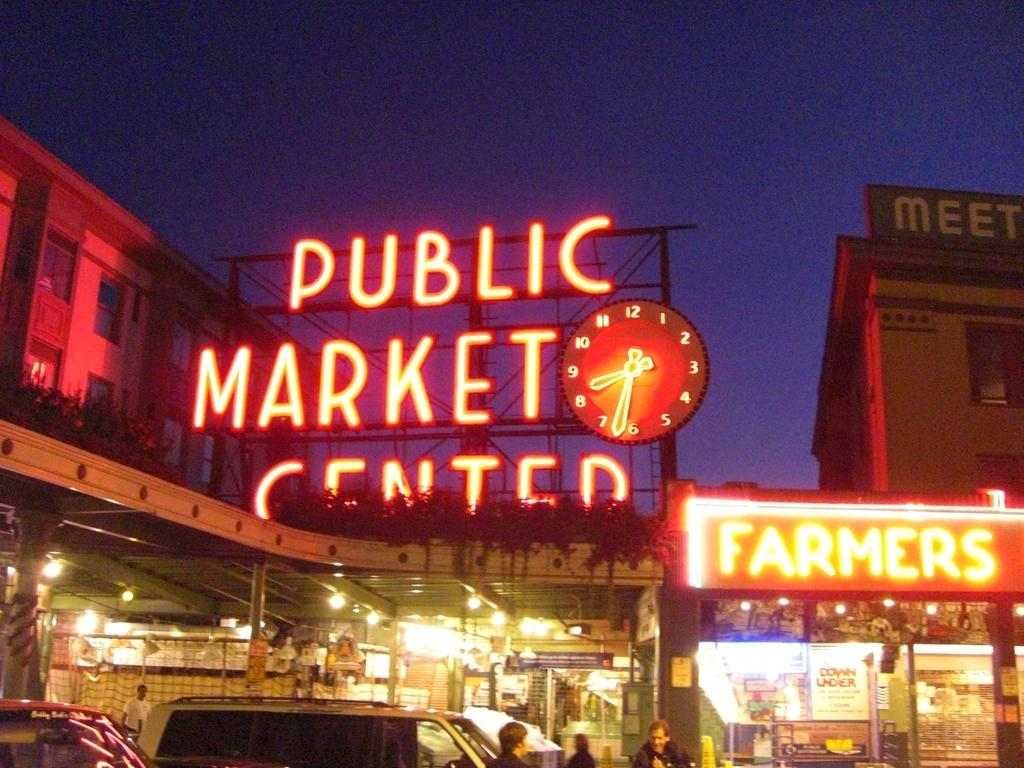What type of structures can be seen in the image? There are buildings in the image. What type of establishments are present in the image? There are shops in the image. What can be seen on the boards in the image? There are boards with text in the image. What is the purpose of the stand in the image? The stand in the image is likely used for displaying or selling items. Who is present in the image? There are people in the image. What type of transportation is visible in the image? There are vehicles in the image. What type of illumination is present in the image? There are lights in the image. What is visible in the background of the image? The sky is visible in the image. Can you tell me how many snakes are slithering around the shops in the image? There are no snakes present in the image; it features buildings, shops, boards with text, a stand, people, vehicles, lights, and the sky. What type of emotion is being expressed by the people in the image? The image does not convey any specific emotions, and we cannot determine the feelings of the people based on the provided facts. 